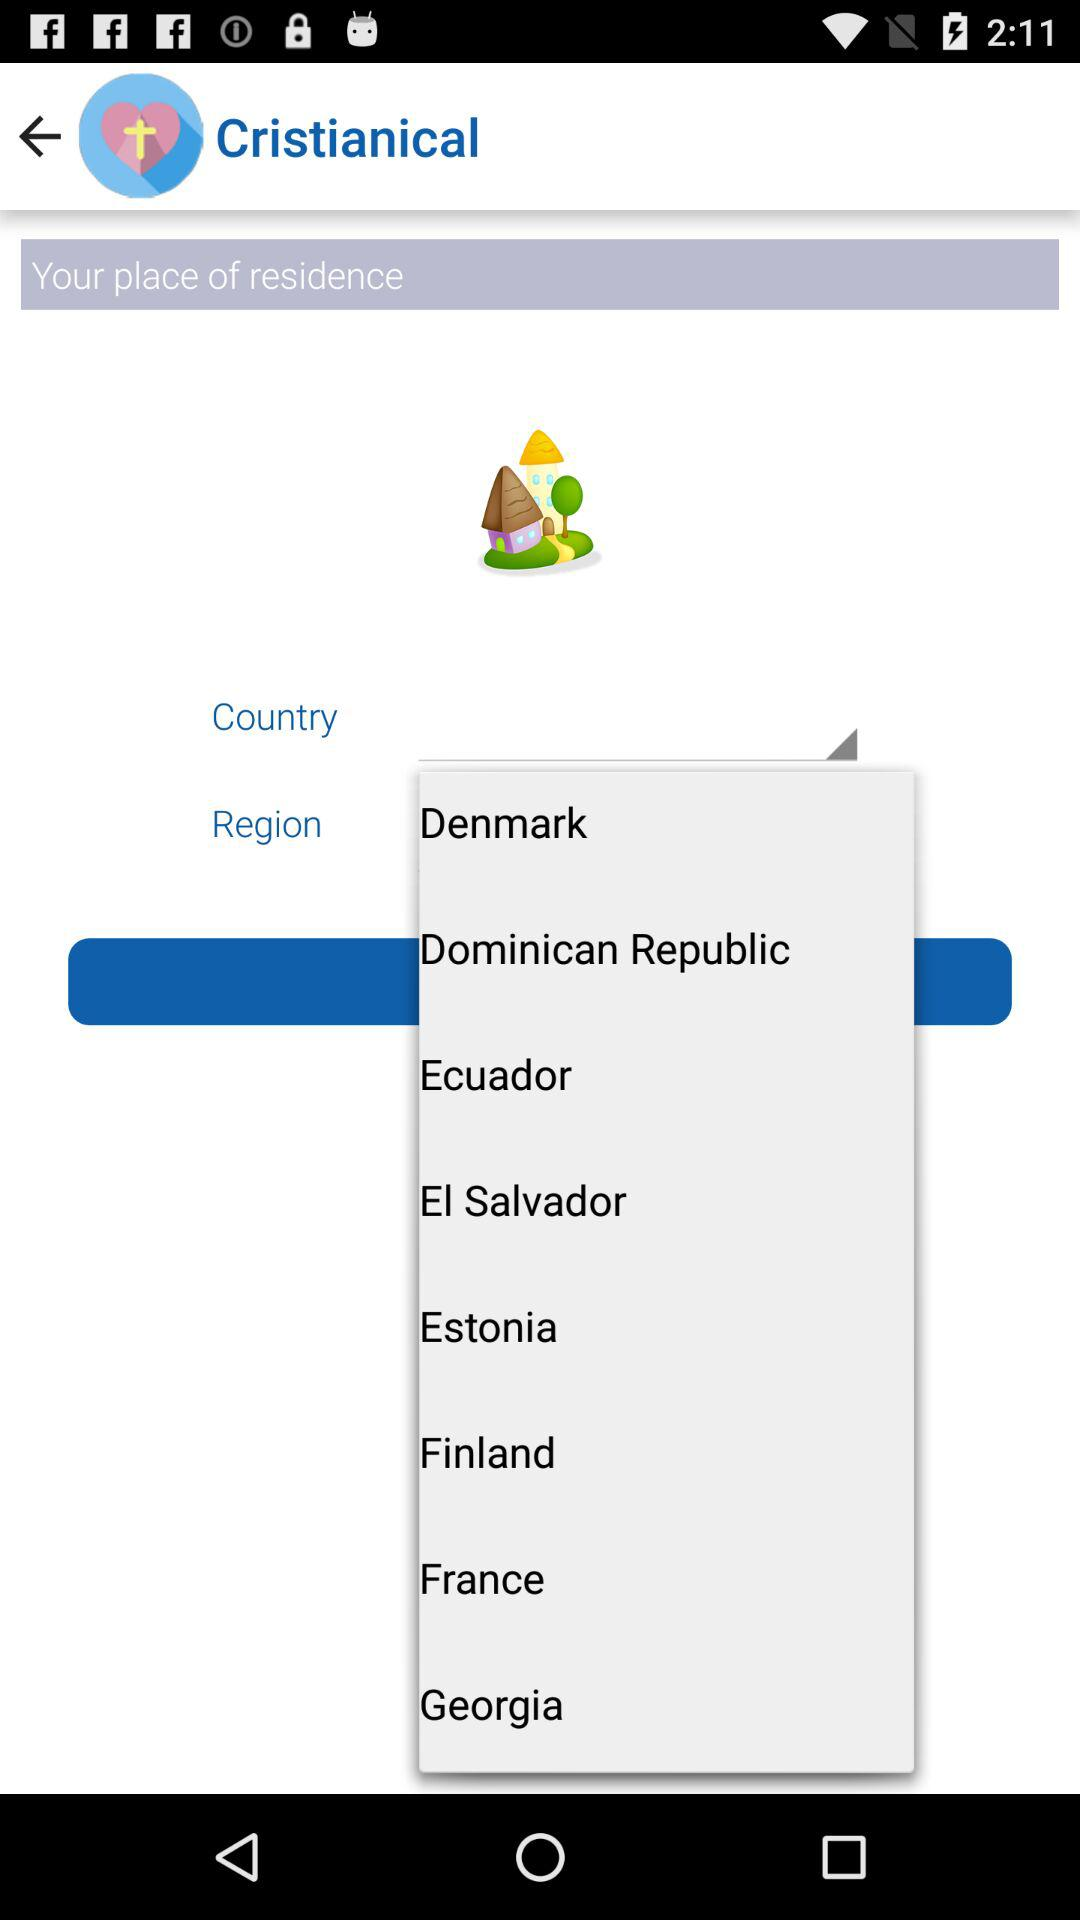What are the country options available in the list? The country's options available are: "Denmark", "Dominican Republic", "Ecuador", "El Salvador", "Estonia", " Finland", "France", and "Georgia". 